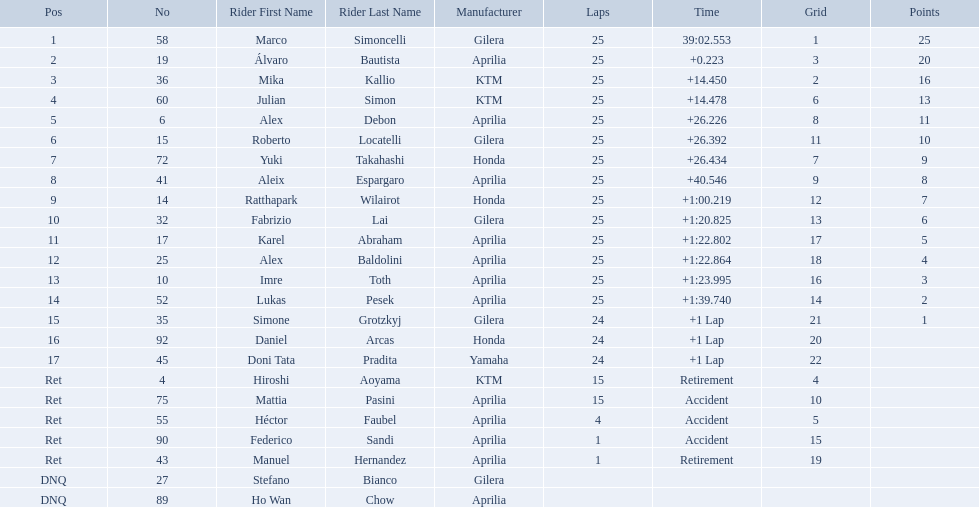How many laps did marco perform? 25. How many laps did hiroshi perform? 15. Which of these numbers are higher? 25. Who swam this number of laps? Marco Simoncelli. What player number is marked #1 for the australian motorcycle grand prix? 58. Who is the rider that represents the #58 in the australian motorcycle grand prix? Marco Simoncelli. 